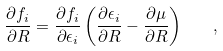Convert formula to latex. <formula><loc_0><loc_0><loc_500><loc_500>\frac { \partial f _ { i } } { \partial { R } } = \frac { \partial f _ { i } } { \partial \epsilon _ { i } } \left ( \frac { \partial \epsilon _ { i } } { \partial { R } } - \frac { \partial \mu } { \partial { R } } \right ) \quad ,</formula> 